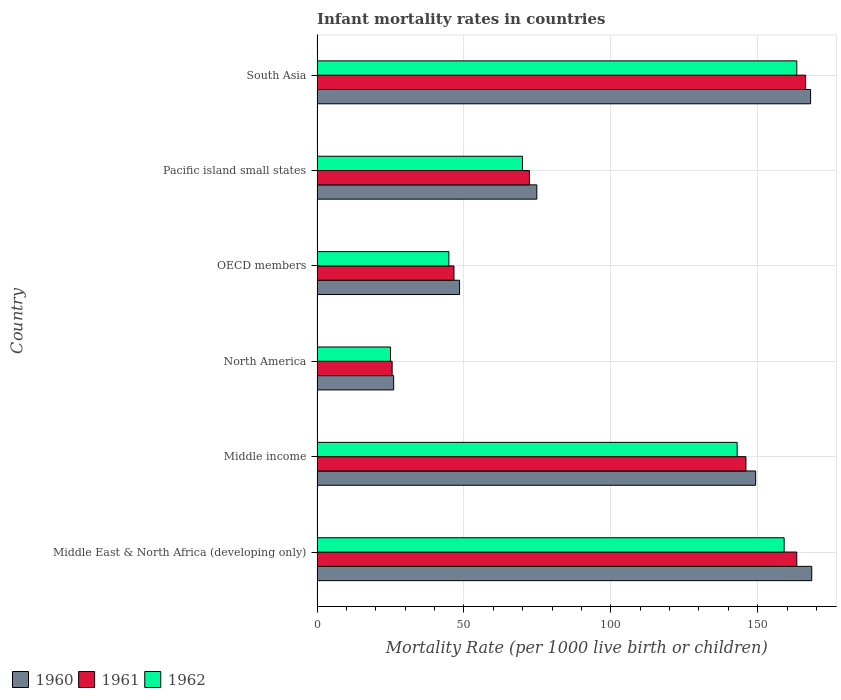How many groups of bars are there?
Your answer should be compact. 6. Are the number of bars per tick equal to the number of legend labels?
Provide a short and direct response. Yes. What is the label of the 2nd group of bars from the top?
Offer a terse response. Pacific island small states. What is the infant mortality rate in 1961 in South Asia?
Provide a short and direct response. 166.3. Across all countries, what is the maximum infant mortality rate in 1962?
Your answer should be compact. 163.3. Across all countries, what is the minimum infant mortality rate in 1960?
Your answer should be compact. 26.08. In which country was the infant mortality rate in 1962 maximum?
Your response must be concise. South Asia. In which country was the infant mortality rate in 1960 minimum?
Keep it short and to the point. North America. What is the total infant mortality rate in 1961 in the graph?
Provide a short and direct response. 620.06. What is the difference between the infant mortality rate in 1960 in Middle East & North Africa (developing only) and that in Pacific island small states?
Offer a terse response. 93.58. What is the difference between the infant mortality rate in 1961 in Middle income and the infant mortality rate in 1960 in OECD members?
Give a very brief answer. 97.49. What is the average infant mortality rate in 1961 per country?
Give a very brief answer. 103.34. What is the difference between the infant mortality rate in 1960 and infant mortality rate in 1961 in OECD members?
Give a very brief answer. 1.89. What is the ratio of the infant mortality rate in 1961 in Middle income to that in OECD members?
Make the answer very short. 3.13. What is the difference between the highest and the second highest infant mortality rate in 1962?
Your answer should be very brief. 4.3. What is the difference between the highest and the lowest infant mortality rate in 1962?
Provide a succinct answer. 138.29. In how many countries, is the infant mortality rate in 1961 greater than the average infant mortality rate in 1961 taken over all countries?
Ensure brevity in your answer.  3. What does the 2nd bar from the top in Pacific island small states represents?
Keep it short and to the point. 1961. Are all the bars in the graph horizontal?
Your answer should be very brief. Yes. Does the graph contain grids?
Provide a short and direct response. Yes. How are the legend labels stacked?
Provide a short and direct response. Horizontal. What is the title of the graph?
Give a very brief answer. Infant mortality rates in countries. Does "2000" appear as one of the legend labels in the graph?
Keep it short and to the point. No. What is the label or title of the X-axis?
Offer a very short reply. Mortality Rate (per 1000 live birth or children). What is the label or title of the Y-axis?
Offer a terse response. Country. What is the Mortality Rate (per 1000 live birth or children) of 1960 in Middle East & North Africa (developing only)?
Make the answer very short. 168.4. What is the Mortality Rate (per 1000 live birth or children) of 1961 in Middle East & North Africa (developing only)?
Provide a short and direct response. 163.3. What is the Mortality Rate (per 1000 live birth or children) in 1962 in Middle East & North Africa (developing only)?
Give a very brief answer. 159. What is the Mortality Rate (per 1000 live birth or children) of 1960 in Middle income?
Offer a very short reply. 149.3. What is the Mortality Rate (per 1000 live birth or children) in 1961 in Middle income?
Your answer should be very brief. 146. What is the Mortality Rate (per 1000 live birth or children) in 1962 in Middle income?
Ensure brevity in your answer.  143. What is the Mortality Rate (per 1000 live birth or children) in 1960 in North America?
Provide a short and direct response. 26.08. What is the Mortality Rate (per 1000 live birth or children) of 1961 in North America?
Make the answer very short. 25.56. What is the Mortality Rate (per 1000 live birth or children) of 1962 in North America?
Your answer should be compact. 25.01. What is the Mortality Rate (per 1000 live birth or children) of 1960 in OECD members?
Ensure brevity in your answer.  48.51. What is the Mortality Rate (per 1000 live birth or children) in 1961 in OECD members?
Your answer should be compact. 46.61. What is the Mortality Rate (per 1000 live birth or children) in 1962 in OECD members?
Keep it short and to the point. 44.87. What is the Mortality Rate (per 1000 live birth or children) of 1960 in Pacific island small states?
Keep it short and to the point. 74.82. What is the Mortality Rate (per 1000 live birth or children) of 1961 in Pacific island small states?
Offer a terse response. 72.29. What is the Mortality Rate (per 1000 live birth or children) of 1962 in Pacific island small states?
Provide a succinct answer. 69.93. What is the Mortality Rate (per 1000 live birth or children) of 1960 in South Asia?
Offer a terse response. 168. What is the Mortality Rate (per 1000 live birth or children) of 1961 in South Asia?
Ensure brevity in your answer.  166.3. What is the Mortality Rate (per 1000 live birth or children) of 1962 in South Asia?
Offer a very short reply. 163.3. Across all countries, what is the maximum Mortality Rate (per 1000 live birth or children) of 1960?
Offer a terse response. 168.4. Across all countries, what is the maximum Mortality Rate (per 1000 live birth or children) in 1961?
Offer a very short reply. 166.3. Across all countries, what is the maximum Mortality Rate (per 1000 live birth or children) of 1962?
Ensure brevity in your answer.  163.3. Across all countries, what is the minimum Mortality Rate (per 1000 live birth or children) in 1960?
Give a very brief answer. 26.08. Across all countries, what is the minimum Mortality Rate (per 1000 live birth or children) in 1961?
Provide a succinct answer. 25.56. Across all countries, what is the minimum Mortality Rate (per 1000 live birth or children) of 1962?
Give a very brief answer. 25.01. What is the total Mortality Rate (per 1000 live birth or children) of 1960 in the graph?
Offer a terse response. 635.11. What is the total Mortality Rate (per 1000 live birth or children) in 1961 in the graph?
Offer a very short reply. 620.06. What is the total Mortality Rate (per 1000 live birth or children) in 1962 in the graph?
Your answer should be very brief. 605.1. What is the difference between the Mortality Rate (per 1000 live birth or children) in 1961 in Middle East & North Africa (developing only) and that in Middle income?
Provide a succinct answer. 17.3. What is the difference between the Mortality Rate (per 1000 live birth or children) in 1960 in Middle East & North Africa (developing only) and that in North America?
Your response must be concise. 142.32. What is the difference between the Mortality Rate (per 1000 live birth or children) of 1961 in Middle East & North Africa (developing only) and that in North America?
Your response must be concise. 137.74. What is the difference between the Mortality Rate (per 1000 live birth or children) in 1962 in Middle East & North Africa (developing only) and that in North America?
Provide a short and direct response. 133.99. What is the difference between the Mortality Rate (per 1000 live birth or children) in 1960 in Middle East & North Africa (developing only) and that in OECD members?
Your answer should be very brief. 119.89. What is the difference between the Mortality Rate (per 1000 live birth or children) in 1961 in Middle East & North Africa (developing only) and that in OECD members?
Your answer should be compact. 116.69. What is the difference between the Mortality Rate (per 1000 live birth or children) of 1962 in Middle East & North Africa (developing only) and that in OECD members?
Your response must be concise. 114.13. What is the difference between the Mortality Rate (per 1000 live birth or children) in 1960 in Middle East & North Africa (developing only) and that in Pacific island small states?
Your response must be concise. 93.58. What is the difference between the Mortality Rate (per 1000 live birth or children) in 1961 in Middle East & North Africa (developing only) and that in Pacific island small states?
Your answer should be very brief. 91.01. What is the difference between the Mortality Rate (per 1000 live birth or children) in 1962 in Middle East & North Africa (developing only) and that in Pacific island small states?
Your response must be concise. 89.07. What is the difference between the Mortality Rate (per 1000 live birth or children) in 1960 in Middle East & North Africa (developing only) and that in South Asia?
Keep it short and to the point. 0.4. What is the difference between the Mortality Rate (per 1000 live birth or children) of 1960 in Middle income and that in North America?
Offer a terse response. 123.22. What is the difference between the Mortality Rate (per 1000 live birth or children) in 1961 in Middle income and that in North America?
Offer a terse response. 120.44. What is the difference between the Mortality Rate (per 1000 live birth or children) of 1962 in Middle income and that in North America?
Your answer should be compact. 117.99. What is the difference between the Mortality Rate (per 1000 live birth or children) in 1960 in Middle income and that in OECD members?
Make the answer very short. 100.79. What is the difference between the Mortality Rate (per 1000 live birth or children) in 1961 in Middle income and that in OECD members?
Your answer should be compact. 99.39. What is the difference between the Mortality Rate (per 1000 live birth or children) in 1962 in Middle income and that in OECD members?
Your response must be concise. 98.13. What is the difference between the Mortality Rate (per 1000 live birth or children) in 1960 in Middle income and that in Pacific island small states?
Your response must be concise. 74.48. What is the difference between the Mortality Rate (per 1000 live birth or children) of 1961 in Middle income and that in Pacific island small states?
Provide a succinct answer. 73.71. What is the difference between the Mortality Rate (per 1000 live birth or children) in 1962 in Middle income and that in Pacific island small states?
Provide a short and direct response. 73.07. What is the difference between the Mortality Rate (per 1000 live birth or children) of 1960 in Middle income and that in South Asia?
Your response must be concise. -18.7. What is the difference between the Mortality Rate (per 1000 live birth or children) of 1961 in Middle income and that in South Asia?
Provide a succinct answer. -20.3. What is the difference between the Mortality Rate (per 1000 live birth or children) of 1962 in Middle income and that in South Asia?
Your answer should be compact. -20.3. What is the difference between the Mortality Rate (per 1000 live birth or children) of 1960 in North America and that in OECD members?
Give a very brief answer. -22.42. What is the difference between the Mortality Rate (per 1000 live birth or children) in 1961 in North America and that in OECD members?
Give a very brief answer. -21.06. What is the difference between the Mortality Rate (per 1000 live birth or children) of 1962 in North America and that in OECD members?
Provide a short and direct response. -19.86. What is the difference between the Mortality Rate (per 1000 live birth or children) in 1960 in North America and that in Pacific island small states?
Ensure brevity in your answer.  -48.73. What is the difference between the Mortality Rate (per 1000 live birth or children) in 1961 in North America and that in Pacific island small states?
Give a very brief answer. -46.74. What is the difference between the Mortality Rate (per 1000 live birth or children) of 1962 in North America and that in Pacific island small states?
Offer a terse response. -44.92. What is the difference between the Mortality Rate (per 1000 live birth or children) in 1960 in North America and that in South Asia?
Give a very brief answer. -141.92. What is the difference between the Mortality Rate (per 1000 live birth or children) in 1961 in North America and that in South Asia?
Your answer should be very brief. -140.74. What is the difference between the Mortality Rate (per 1000 live birth or children) of 1962 in North America and that in South Asia?
Provide a short and direct response. -138.29. What is the difference between the Mortality Rate (per 1000 live birth or children) in 1960 in OECD members and that in Pacific island small states?
Provide a succinct answer. -26.31. What is the difference between the Mortality Rate (per 1000 live birth or children) in 1961 in OECD members and that in Pacific island small states?
Provide a succinct answer. -25.68. What is the difference between the Mortality Rate (per 1000 live birth or children) of 1962 in OECD members and that in Pacific island small states?
Make the answer very short. -25.05. What is the difference between the Mortality Rate (per 1000 live birth or children) of 1960 in OECD members and that in South Asia?
Provide a succinct answer. -119.49. What is the difference between the Mortality Rate (per 1000 live birth or children) of 1961 in OECD members and that in South Asia?
Keep it short and to the point. -119.69. What is the difference between the Mortality Rate (per 1000 live birth or children) of 1962 in OECD members and that in South Asia?
Offer a terse response. -118.43. What is the difference between the Mortality Rate (per 1000 live birth or children) of 1960 in Pacific island small states and that in South Asia?
Give a very brief answer. -93.18. What is the difference between the Mortality Rate (per 1000 live birth or children) of 1961 in Pacific island small states and that in South Asia?
Keep it short and to the point. -94.01. What is the difference between the Mortality Rate (per 1000 live birth or children) of 1962 in Pacific island small states and that in South Asia?
Your answer should be compact. -93.37. What is the difference between the Mortality Rate (per 1000 live birth or children) of 1960 in Middle East & North Africa (developing only) and the Mortality Rate (per 1000 live birth or children) of 1961 in Middle income?
Provide a short and direct response. 22.4. What is the difference between the Mortality Rate (per 1000 live birth or children) in 1960 in Middle East & North Africa (developing only) and the Mortality Rate (per 1000 live birth or children) in 1962 in Middle income?
Offer a terse response. 25.4. What is the difference between the Mortality Rate (per 1000 live birth or children) in 1961 in Middle East & North Africa (developing only) and the Mortality Rate (per 1000 live birth or children) in 1962 in Middle income?
Ensure brevity in your answer.  20.3. What is the difference between the Mortality Rate (per 1000 live birth or children) of 1960 in Middle East & North Africa (developing only) and the Mortality Rate (per 1000 live birth or children) of 1961 in North America?
Keep it short and to the point. 142.84. What is the difference between the Mortality Rate (per 1000 live birth or children) in 1960 in Middle East & North Africa (developing only) and the Mortality Rate (per 1000 live birth or children) in 1962 in North America?
Offer a very short reply. 143.39. What is the difference between the Mortality Rate (per 1000 live birth or children) of 1961 in Middle East & North Africa (developing only) and the Mortality Rate (per 1000 live birth or children) of 1962 in North America?
Your response must be concise. 138.29. What is the difference between the Mortality Rate (per 1000 live birth or children) in 1960 in Middle East & North Africa (developing only) and the Mortality Rate (per 1000 live birth or children) in 1961 in OECD members?
Make the answer very short. 121.79. What is the difference between the Mortality Rate (per 1000 live birth or children) of 1960 in Middle East & North Africa (developing only) and the Mortality Rate (per 1000 live birth or children) of 1962 in OECD members?
Your response must be concise. 123.53. What is the difference between the Mortality Rate (per 1000 live birth or children) in 1961 in Middle East & North Africa (developing only) and the Mortality Rate (per 1000 live birth or children) in 1962 in OECD members?
Offer a very short reply. 118.43. What is the difference between the Mortality Rate (per 1000 live birth or children) in 1960 in Middle East & North Africa (developing only) and the Mortality Rate (per 1000 live birth or children) in 1961 in Pacific island small states?
Keep it short and to the point. 96.11. What is the difference between the Mortality Rate (per 1000 live birth or children) in 1960 in Middle East & North Africa (developing only) and the Mortality Rate (per 1000 live birth or children) in 1962 in Pacific island small states?
Offer a very short reply. 98.47. What is the difference between the Mortality Rate (per 1000 live birth or children) of 1961 in Middle East & North Africa (developing only) and the Mortality Rate (per 1000 live birth or children) of 1962 in Pacific island small states?
Your answer should be very brief. 93.37. What is the difference between the Mortality Rate (per 1000 live birth or children) of 1960 in Middle East & North Africa (developing only) and the Mortality Rate (per 1000 live birth or children) of 1961 in South Asia?
Make the answer very short. 2.1. What is the difference between the Mortality Rate (per 1000 live birth or children) of 1960 in Middle income and the Mortality Rate (per 1000 live birth or children) of 1961 in North America?
Provide a succinct answer. 123.74. What is the difference between the Mortality Rate (per 1000 live birth or children) of 1960 in Middle income and the Mortality Rate (per 1000 live birth or children) of 1962 in North America?
Provide a short and direct response. 124.29. What is the difference between the Mortality Rate (per 1000 live birth or children) in 1961 in Middle income and the Mortality Rate (per 1000 live birth or children) in 1962 in North America?
Your answer should be very brief. 120.99. What is the difference between the Mortality Rate (per 1000 live birth or children) in 1960 in Middle income and the Mortality Rate (per 1000 live birth or children) in 1961 in OECD members?
Provide a succinct answer. 102.69. What is the difference between the Mortality Rate (per 1000 live birth or children) in 1960 in Middle income and the Mortality Rate (per 1000 live birth or children) in 1962 in OECD members?
Keep it short and to the point. 104.43. What is the difference between the Mortality Rate (per 1000 live birth or children) in 1961 in Middle income and the Mortality Rate (per 1000 live birth or children) in 1962 in OECD members?
Offer a terse response. 101.13. What is the difference between the Mortality Rate (per 1000 live birth or children) in 1960 in Middle income and the Mortality Rate (per 1000 live birth or children) in 1961 in Pacific island small states?
Offer a very short reply. 77.01. What is the difference between the Mortality Rate (per 1000 live birth or children) in 1960 in Middle income and the Mortality Rate (per 1000 live birth or children) in 1962 in Pacific island small states?
Your answer should be very brief. 79.37. What is the difference between the Mortality Rate (per 1000 live birth or children) in 1961 in Middle income and the Mortality Rate (per 1000 live birth or children) in 1962 in Pacific island small states?
Offer a terse response. 76.07. What is the difference between the Mortality Rate (per 1000 live birth or children) in 1961 in Middle income and the Mortality Rate (per 1000 live birth or children) in 1962 in South Asia?
Offer a very short reply. -17.3. What is the difference between the Mortality Rate (per 1000 live birth or children) in 1960 in North America and the Mortality Rate (per 1000 live birth or children) in 1961 in OECD members?
Make the answer very short. -20.53. What is the difference between the Mortality Rate (per 1000 live birth or children) in 1960 in North America and the Mortality Rate (per 1000 live birth or children) in 1962 in OECD members?
Keep it short and to the point. -18.79. What is the difference between the Mortality Rate (per 1000 live birth or children) in 1961 in North America and the Mortality Rate (per 1000 live birth or children) in 1962 in OECD members?
Ensure brevity in your answer.  -19.32. What is the difference between the Mortality Rate (per 1000 live birth or children) in 1960 in North America and the Mortality Rate (per 1000 live birth or children) in 1961 in Pacific island small states?
Offer a terse response. -46.21. What is the difference between the Mortality Rate (per 1000 live birth or children) in 1960 in North America and the Mortality Rate (per 1000 live birth or children) in 1962 in Pacific island small states?
Offer a very short reply. -43.84. What is the difference between the Mortality Rate (per 1000 live birth or children) in 1961 in North America and the Mortality Rate (per 1000 live birth or children) in 1962 in Pacific island small states?
Offer a terse response. -44.37. What is the difference between the Mortality Rate (per 1000 live birth or children) in 1960 in North America and the Mortality Rate (per 1000 live birth or children) in 1961 in South Asia?
Your response must be concise. -140.22. What is the difference between the Mortality Rate (per 1000 live birth or children) of 1960 in North America and the Mortality Rate (per 1000 live birth or children) of 1962 in South Asia?
Provide a short and direct response. -137.22. What is the difference between the Mortality Rate (per 1000 live birth or children) in 1961 in North America and the Mortality Rate (per 1000 live birth or children) in 1962 in South Asia?
Offer a terse response. -137.74. What is the difference between the Mortality Rate (per 1000 live birth or children) of 1960 in OECD members and the Mortality Rate (per 1000 live birth or children) of 1961 in Pacific island small states?
Make the answer very short. -23.78. What is the difference between the Mortality Rate (per 1000 live birth or children) in 1960 in OECD members and the Mortality Rate (per 1000 live birth or children) in 1962 in Pacific island small states?
Offer a terse response. -21.42. What is the difference between the Mortality Rate (per 1000 live birth or children) in 1961 in OECD members and the Mortality Rate (per 1000 live birth or children) in 1962 in Pacific island small states?
Provide a succinct answer. -23.31. What is the difference between the Mortality Rate (per 1000 live birth or children) in 1960 in OECD members and the Mortality Rate (per 1000 live birth or children) in 1961 in South Asia?
Provide a short and direct response. -117.79. What is the difference between the Mortality Rate (per 1000 live birth or children) in 1960 in OECD members and the Mortality Rate (per 1000 live birth or children) in 1962 in South Asia?
Give a very brief answer. -114.79. What is the difference between the Mortality Rate (per 1000 live birth or children) in 1961 in OECD members and the Mortality Rate (per 1000 live birth or children) in 1962 in South Asia?
Your answer should be compact. -116.69. What is the difference between the Mortality Rate (per 1000 live birth or children) of 1960 in Pacific island small states and the Mortality Rate (per 1000 live birth or children) of 1961 in South Asia?
Provide a succinct answer. -91.48. What is the difference between the Mortality Rate (per 1000 live birth or children) in 1960 in Pacific island small states and the Mortality Rate (per 1000 live birth or children) in 1962 in South Asia?
Your answer should be very brief. -88.48. What is the difference between the Mortality Rate (per 1000 live birth or children) of 1961 in Pacific island small states and the Mortality Rate (per 1000 live birth or children) of 1962 in South Asia?
Keep it short and to the point. -91.01. What is the average Mortality Rate (per 1000 live birth or children) of 1960 per country?
Your response must be concise. 105.85. What is the average Mortality Rate (per 1000 live birth or children) in 1961 per country?
Keep it short and to the point. 103.34. What is the average Mortality Rate (per 1000 live birth or children) in 1962 per country?
Your response must be concise. 100.85. What is the difference between the Mortality Rate (per 1000 live birth or children) of 1960 and Mortality Rate (per 1000 live birth or children) of 1962 in Middle East & North Africa (developing only)?
Your answer should be very brief. 9.4. What is the difference between the Mortality Rate (per 1000 live birth or children) of 1961 and Mortality Rate (per 1000 live birth or children) of 1962 in Middle East & North Africa (developing only)?
Your response must be concise. 4.3. What is the difference between the Mortality Rate (per 1000 live birth or children) of 1960 and Mortality Rate (per 1000 live birth or children) of 1961 in Middle income?
Keep it short and to the point. 3.3. What is the difference between the Mortality Rate (per 1000 live birth or children) in 1961 and Mortality Rate (per 1000 live birth or children) in 1962 in Middle income?
Keep it short and to the point. 3. What is the difference between the Mortality Rate (per 1000 live birth or children) of 1960 and Mortality Rate (per 1000 live birth or children) of 1961 in North America?
Your response must be concise. 0.53. What is the difference between the Mortality Rate (per 1000 live birth or children) of 1960 and Mortality Rate (per 1000 live birth or children) of 1962 in North America?
Provide a short and direct response. 1.08. What is the difference between the Mortality Rate (per 1000 live birth or children) of 1961 and Mortality Rate (per 1000 live birth or children) of 1962 in North America?
Make the answer very short. 0.55. What is the difference between the Mortality Rate (per 1000 live birth or children) of 1960 and Mortality Rate (per 1000 live birth or children) of 1961 in OECD members?
Offer a terse response. 1.89. What is the difference between the Mortality Rate (per 1000 live birth or children) in 1960 and Mortality Rate (per 1000 live birth or children) in 1962 in OECD members?
Keep it short and to the point. 3.64. What is the difference between the Mortality Rate (per 1000 live birth or children) in 1961 and Mortality Rate (per 1000 live birth or children) in 1962 in OECD members?
Your response must be concise. 1.74. What is the difference between the Mortality Rate (per 1000 live birth or children) in 1960 and Mortality Rate (per 1000 live birth or children) in 1961 in Pacific island small states?
Give a very brief answer. 2.53. What is the difference between the Mortality Rate (per 1000 live birth or children) in 1960 and Mortality Rate (per 1000 live birth or children) in 1962 in Pacific island small states?
Your response must be concise. 4.89. What is the difference between the Mortality Rate (per 1000 live birth or children) in 1961 and Mortality Rate (per 1000 live birth or children) in 1962 in Pacific island small states?
Your answer should be very brief. 2.37. What is the difference between the Mortality Rate (per 1000 live birth or children) in 1960 and Mortality Rate (per 1000 live birth or children) in 1961 in South Asia?
Your response must be concise. 1.7. What is the difference between the Mortality Rate (per 1000 live birth or children) of 1960 and Mortality Rate (per 1000 live birth or children) of 1962 in South Asia?
Your response must be concise. 4.7. What is the ratio of the Mortality Rate (per 1000 live birth or children) in 1960 in Middle East & North Africa (developing only) to that in Middle income?
Your answer should be compact. 1.13. What is the ratio of the Mortality Rate (per 1000 live birth or children) of 1961 in Middle East & North Africa (developing only) to that in Middle income?
Provide a succinct answer. 1.12. What is the ratio of the Mortality Rate (per 1000 live birth or children) in 1962 in Middle East & North Africa (developing only) to that in Middle income?
Offer a terse response. 1.11. What is the ratio of the Mortality Rate (per 1000 live birth or children) of 1960 in Middle East & North Africa (developing only) to that in North America?
Offer a very short reply. 6.46. What is the ratio of the Mortality Rate (per 1000 live birth or children) of 1961 in Middle East & North Africa (developing only) to that in North America?
Ensure brevity in your answer.  6.39. What is the ratio of the Mortality Rate (per 1000 live birth or children) of 1962 in Middle East & North Africa (developing only) to that in North America?
Offer a very short reply. 6.36. What is the ratio of the Mortality Rate (per 1000 live birth or children) of 1960 in Middle East & North Africa (developing only) to that in OECD members?
Offer a terse response. 3.47. What is the ratio of the Mortality Rate (per 1000 live birth or children) of 1961 in Middle East & North Africa (developing only) to that in OECD members?
Provide a succinct answer. 3.5. What is the ratio of the Mortality Rate (per 1000 live birth or children) of 1962 in Middle East & North Africa (developing only) to that in OECD members?
Your answer should be very brief. 3.54. What is the ratio of the Mortality Rate (per 1000 live birth or children) in 1960 in Middle East & North Africa (developing only) to that in Pacific island small states?
Provide a short and direct response. 2.25. What is the ratio of the Mortality Rate (per 1000 live birth or children) in 1961 in Middle East & North Africa (developing only) to that in Pacific island small states?
Provide a succinct answer. 2.26. What is the ratio of the Mortality Rate (per 1000 live birth or children) of 1962 in Middle East & North Africa (developing only) to that in Pacific island small states?
Offer a very short reply. 2.27. What is the ratio of the Mortality Rate (per 1000 live birth or children) in 1960 in Middle East & North Africa (developing only) to that in South Asia?
Offer a terse response. 1. What is the ratio of the Mortality Rate (per 1000 live birth or children) in 1961 in Middle East & North Africa (developing only) to that in South Asia?
Offer a very short reply. 0.98. What is the ratio of the Mortality Rate (per 1000 live birth or children) of 1962 in Middle East & North Africa (developing only) to that in South Asia?
Your answer should be compact. 0.97. What is the ratio of the Mortality Rate (per 1000 live birth or children) of 1960 in Middle income to that in North America?
Provide a succinct answer. 5.72. What is the ratio of the Mortality Rate (per 1000 live birth or children) of 1961 in Middle income to that in North America?
Provide a succinct answer. 5.71. What is the ratio of the Mortality Rate (per 1000 live birth or children) of 1962 in Middle income to that in North America?
Your response must be concise. 5.72. What is the ratio of the Mortality Rate (per 1000 live birth or children) in 1960 in Middle income to that in OECD members?
Ensure brevity in your answer.  3.08. What is the ratio of the Mortality Rate (per 1000 live birth or children) in 1961 in Middle income to that in OECD members?
Give a very brief answer. 3.13. What is the ratio of the Mortality Rate (per 1000 live birth or children) in 1962 in Middle income to that in OECD members?
Give a very brief answer. 3.19. What is the ratio of the Mortality Rate (per 1000 live birth or children) of 1960 in Middle income to that in Pacific island small states?
Offer a terse response. 2. What is the ratio of the Mortality Rate (per 1000 live birth or children) of 1961 in Middle income to that in Pacific island small states?
Your answer should be very brief. 2.02. What is the ratio of the Mortality Rate (per 1000 live birth or children) in 1962 in Middle income to that in Pacific island small states?
Keep it short and to the point. 2.04. What is the ratio of the Mortality Rate (per 1000 live birth or children) in 1960 in Middle income to that in South Asia?
Offer a very short reply. 0.89. What is the ratio of the Mortality Rate (per 1000 live birth or children) of 1961 in Middle income to that in South Asia?
Provide a short and direct response. 0.88. What is the ratio of the Mortality Rate (per 1000 live birth or children) in 1962 in Middle income to that in South Asia?
Offer a very short reply. 0.88. What is the ratio of the Mortality Rate (per 1000 live birth or children) in 1960 in North America to that in OECD members?
Offer a terse response. 0.54. What is the ratio of the Mortality Rate (per 1000 live birth or children) in 1961 in North America to that in OECD members?
Give a very brief answer. 0.55. What is the ratio of the Mortality Rate (per 1000 live birth or children) in 1962 in North America to that in OECD members?
Offer a terse response. 0.56. What is the ratio of the Mortality Rate (per 1000 live birth or children) in 1960 in North America to that in Pacific island small states?
Your answer should be compact. 0.35. What is the ratio of the Mortality Rate (per 1000 live birth or children) of 1961 in North America to that in Pacific island small states?
Give a very brief answer. 0.35. What is the ratio of the Mortality Rate (per 1000 live birth or children) of 1962 in North America to that in Pacific island small states?
Make the answer very short. 0.36. What is the ratio of the Mortality Rate (per 1000 live birth or children) in 1960 in North America to that in South Asia?
Provide a succinct answer. 0.16. What is the ratio of the Mortality Rate (per 1000 live birth or children) in 1961 in North America to that in South Asia?
Your answer should be very brief. 0.15. What is the ratio of the Mortality Rate (per 1000 live birth or children) in 1962 in North America to that in South Asia?
Your answer should be very brief. 0.15. What is the ratio of the Mortality Rate (per 1000 live birth or children) of 1960 in OECD members to that in Pacific island small states?
Offer a terse response. 0.65. What is the ratio of the Mortality Rate (per 1000 live birth or children) in 1961 in OECD members to that in Pacific island small states?
Provide a succinct answer. 0.64. What is the ratio of the Mortality Rate (per 1000 live birth or children) of 1962 in OECD members to that in Pacific island small states?
Your response must be concise. 0.64. What is the ratio of the Mortality Rate (per 1000 live birth or children) of 1960 in OECD members to that in South Asia?
Your answer should be compact. 0.29. What is the ratio of the Mortality Rate (per 1000 live birth or children) in 1961 in OECD members to that in South Asia?
Provide a short and direct response. 0.28. What is the ratio of the Mortality Rate (per 1000 live birth or children) of 1962 in OECD members to that in South Asia?
Your answer should be very brief. 0.27. What is the ratio of the Mortality Rate (per 1000 live birth or children) of 1960 in Pacific island small states to that in South Asia?
Make the answer very short. 0.45. What is the ratio of the Mortality Rate (per 1000 live birth or children) of 1961 in Pacific island small states to that in South Asia?
Ensure brevity in your answer.  0.43. What is the ratio of the Mortality Rate (per 1000 live birth or children) in 1962 in Pacific island small states to that in South Asia?
Keep it short and to the point. 0.43. What is the difference between the highest and the second highest Mortality Rate (per 1000 live birth or children) of 1961?
Offer a very short reply. 3. What is the difference between the highest and the lowest Mortality Rate (per 1000 live birth or children) in 1960?
Offer a very short reply. 142.32. What is the difference between the highest and the lowest Mortality Rate (per 1000 live birth or children) in 1961?
Offer a terse response. 140.74. What is the difference between the highest and the lowest Mortality Rate (per 1000 live birth or children) of 1962?
Your response must be concise. 138.29. 